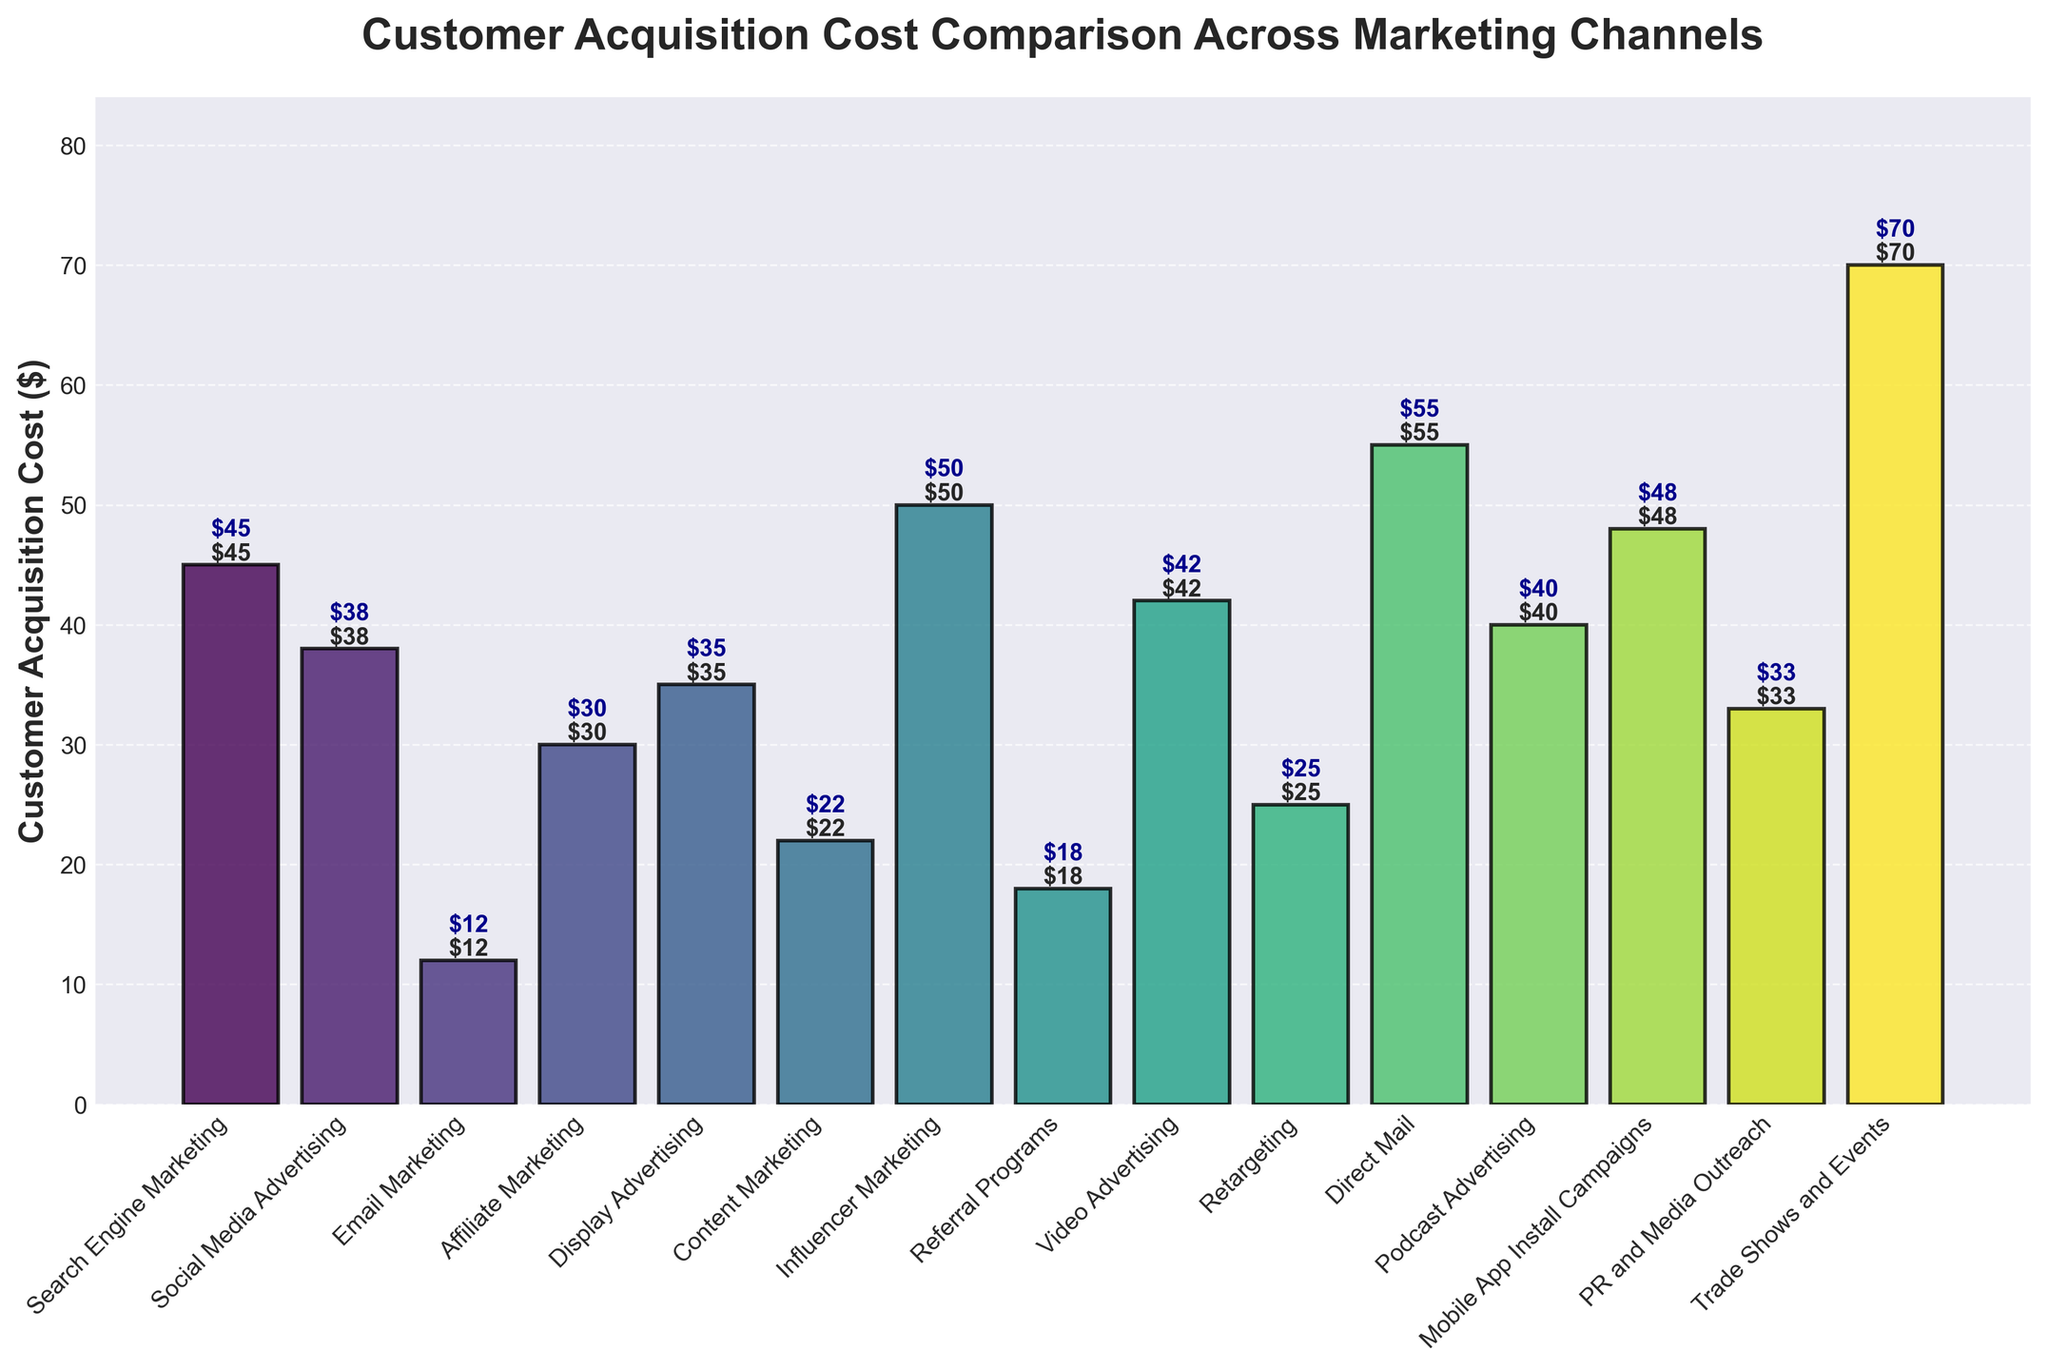What is the Customer Acquisition Cost for Trade Shows and Events? The figure shows the cost for each marketing channel, and Trade Shows and Events has a bar reaching up to $70.
Answer: $70 Which marketing channel has the lowest Customer Acquisition Cost? By visually comparing the heights of the bars, Email Marketing has the smallest height, indicating it has the lowest cost.
Answer: Email Marketing How many marketing channels have an acquisition cost greater than $40? Visually scan the bars and count those which exceed the $40 mark: Search Engine Marketing, Influencer Marketing, Direct Mail, Mobile App Install Campaigns, Podcast Advertising, Trade Shows and Events. This makes a total of 6 channels.
Answer: 6 Compare the acquisition costs of Email Marketing and Display Advertising. The height of the Email Marketing bar is $12, while the Display Advertising bar is $35, making Display Advertising more expensive.
Answer: Display Advertising is more expensive What is the difference in Customer Acquisition Cost between Social Media Advertising and Referral Programs? The bar for Social Media Advertising is at $38 and Referral Programs is $18. Subtracting these values, $38 - $18 = $20.
Answer: $20 What is the average Customer Acquisition Cost for Email Marketing, Content Marketing, and Retargeting? The costs are $12 (Email Marketing), $22 (Content Marketing), and $25 (Retargeting). Average is calculated as ($12 + $22 + $25) / 3 = $59 / 3 ≈ $19.67.
Answer: $19.67 Which marketing channel has the tallest bar, and what is its cost? Scanning the figure, Trade Shows and Events has the tallest bar, with a cost of $70.
Answer: Trade Shows and Events, $70 Is the Customer Acquisition Cost of Mobile App Install Campaigns higher than Video Advertising? The bar for Mobile App Install Campaigns is at $48, while the bar for Video Advertising is at $42. Comparing these values, $48 > $42.
Answer: Yes What percentage of the total acquisition cost is contributed by Influencer Marketing? The total acquisition cost is the sum of all costs: ($45 + $38 + $12 + $30 + $35 + $22 + $50 + $18 + $42 + $25 + $55 + $40 + $48 + $33 + $70) = $563. The Influencer Marketing cost is $50. The percentage is calculated as ($50 / $563) * 100 ≈ 8.88%.
Answer: 8.88% What is the median Customer Acquisition Cost of all the marketing channels? Arrange the costs in ascending order: $12, $18, $22, $25, $30, $33, $35, $38, $40, $42, $45, $48, $50, $55, $70. The median value (the middle value in an ordered list of 15 numbers) is $38.
Answer: $38 